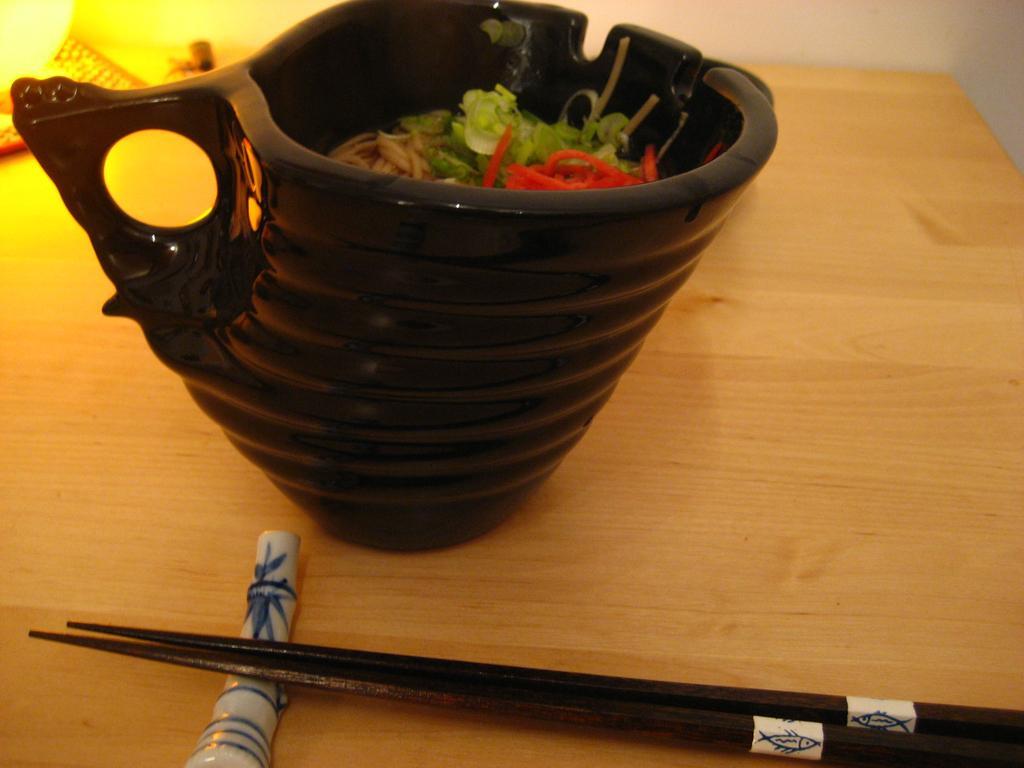Could you give a brief overview of what you see in this image? In this picture we can see a bowl and sticks on the table. 